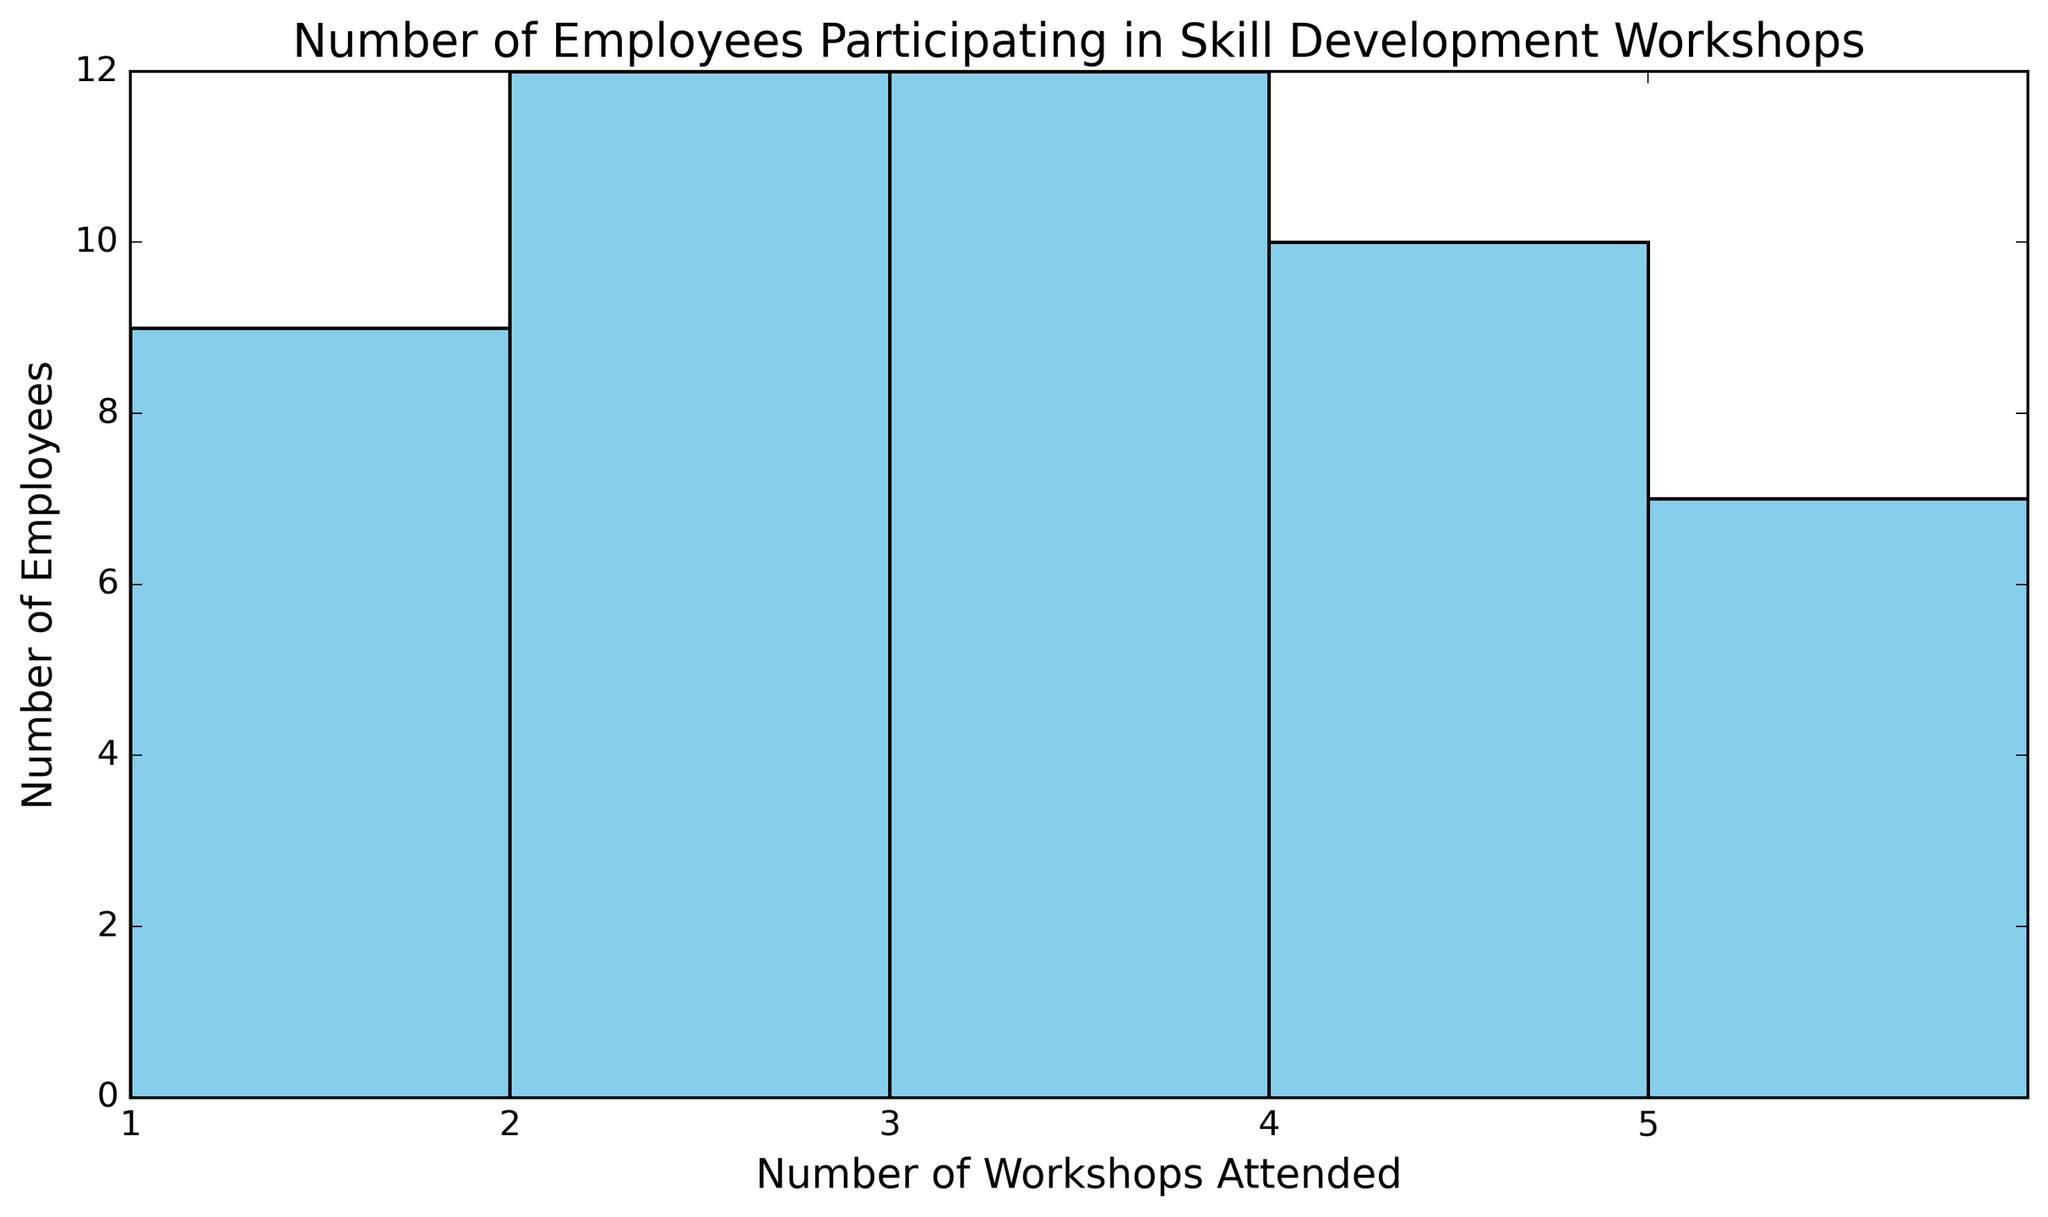How many employees attended 3 workshops? Look at the height of the bar above the label '3' on the x-axis. It represents the number of employees who attended 3 workshops.
Answer: 10 Which number of workshops had the highest participation? Look for the tallest bar in the histogram. The x-axis label for this bar tells us the number of workshops with the highest participation.
Answer: 2 How many more employees attended 1 workshop compared to 5 workshops? Check the heights of the bars above '1' and '5'. Subtract the number of employees who attended 5 workshops from those who attended 1 workshop: 8 (for 1 workshop) - 6 (for 5 workshops).
Answer: 2 What is the total number of employees who attended 4 or more workshops? Add the number of employees from bars representing '4' and '5': 9 (for 4 workshops) + 6 (for 5 workshops).
Answer: 15 Which workshops had equal participation in terms of number of employees? Identify bars with the same height. For example, compare the heights of bars visually and confirm if they match. Both '2' and '3' workshops have bars of equal height, which means they had the same number of employees participating.
Answer: None of the workshops had equal participation 